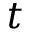Convert formula to latex. <formula><loc_0><loc_0><loc_500><loc_500>t</formula> 